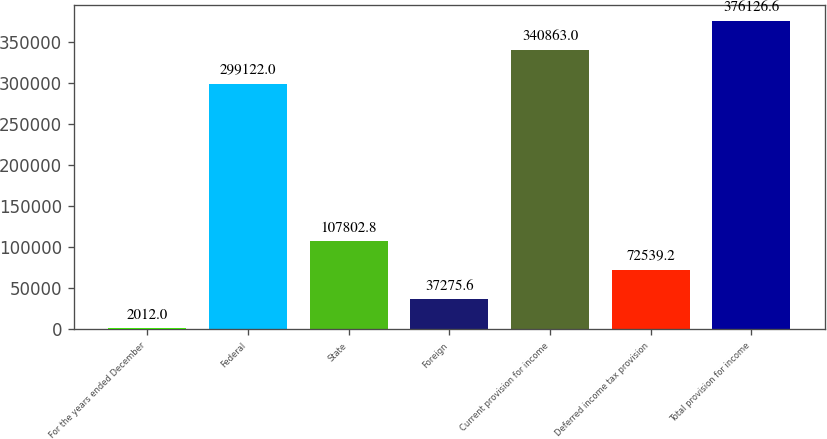<chart> <loc_0><loc_0><loc_500><loc_500><bar_chart><fcel>For the years ended December<fcel>Federal<fcel>State<fcel>Foreign<fcel>Current provision for income<fcel>Deferred income tax provision<fcel>Total provision for income<nl><fcel>2012<fcel>299122<fcel>107803<fcel>37275.6<fcel>340863<fcel>72539.2<fcel>376127<nl></chart> 